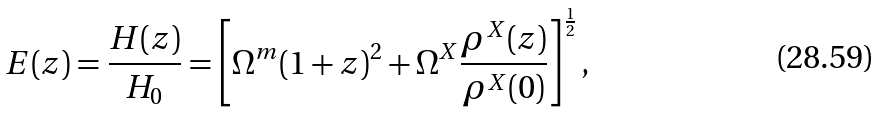Convert formula to latex. <formula><loc_0><loc_0><loc_500><loc_500>E ( z ) = \frac { H ( z ) } { H _ { 0 } } = \left [ \Omega ^ { m } ( 1 + z ) ^ { 2 } + \Omega ^ { X } \frac { \rho ^ { X } ( z ) } { \rho ^ { X } ( 0 ) } \right ] ^ { \frac { 1 } { 2 } } ,</formula> 